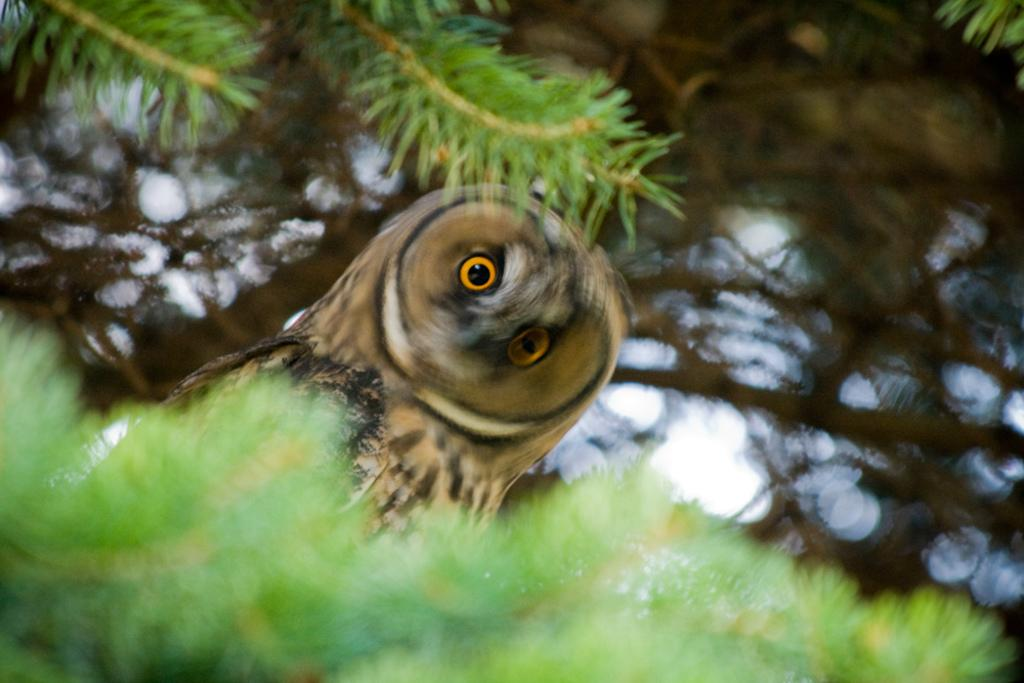What type of animal is in the image? There is an owl in the image. What else can be seen in the image besides the owl? There are leaves in the image. Can you describe the background of the image? The background of the image is blurred. What type of bird is the owl's father in the image? There is no bird or father mentioned in the image; it only features an owl and leaves. 